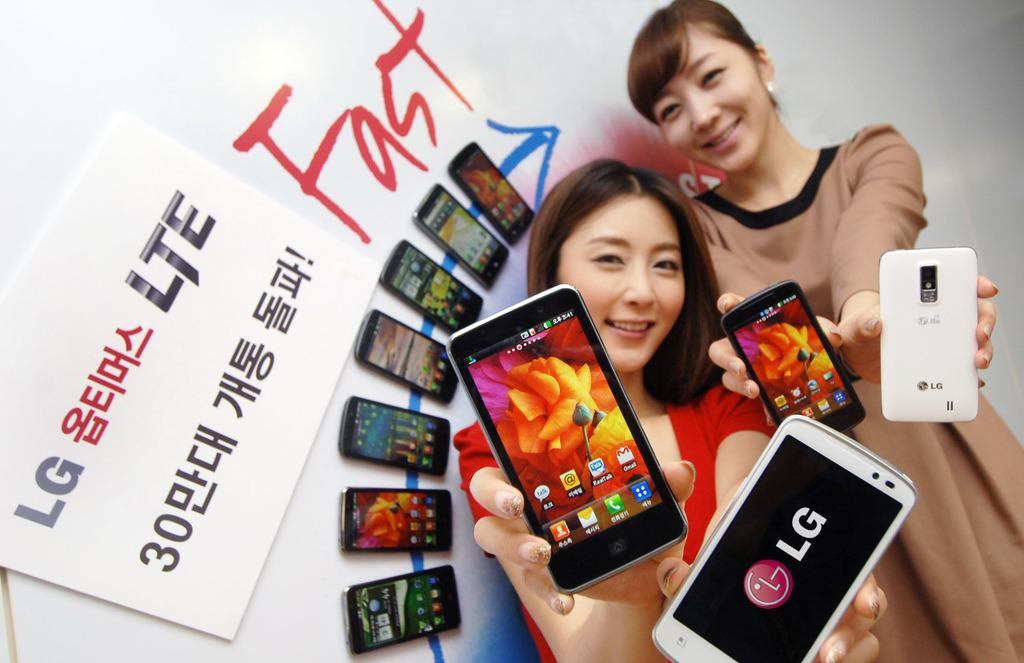<image>
Describe the image concisely. Two girls are holding up cell phones by a sign that says LG LTE. 